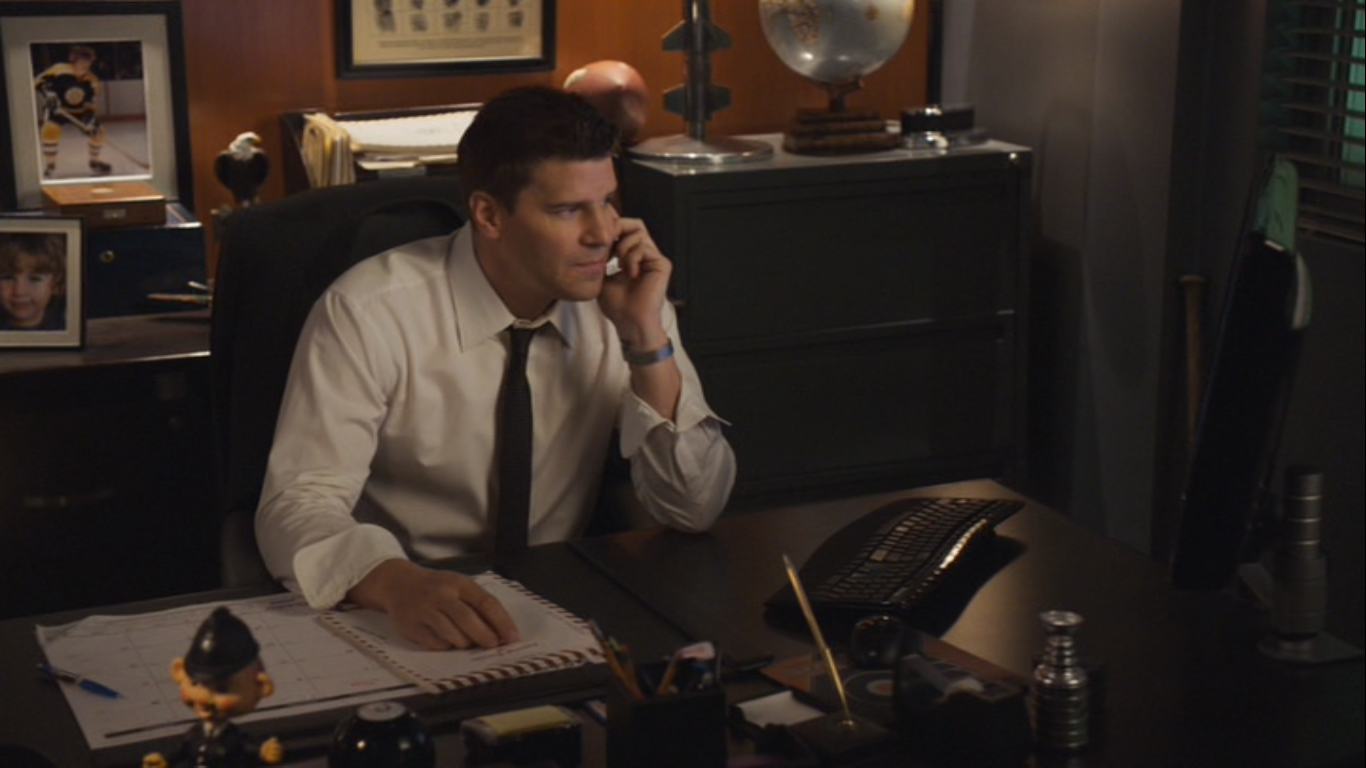What are the key elements in this picture? The photograph features a man in a professional setting, depicted as being focused on a phone conversation. He is well-dressed in a white shirt paired with a dark tie, suggesting a formal workplace. Around him, the office is adorned with personal and professional items: photographs that may imply familial connections, an assortment of office supplies indicating an organized work approach, a computer keyboard implying the use of technology in his tasks, and decorative items like a standing globe and a miniature statue that could reflect personal interests or symbolize aspects of his work. The dark-toned background and window blinds convey a private and possibly high-stakes environment. 